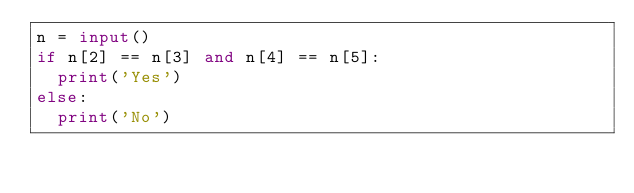Convert code to text. <code><loc_0><loc_0><loc_500><loc_500><_Python_>n = input()
if n[2] == n[3] and n[4] == n[5]:
  print('Yes')
else:
  print('No')
</code> 